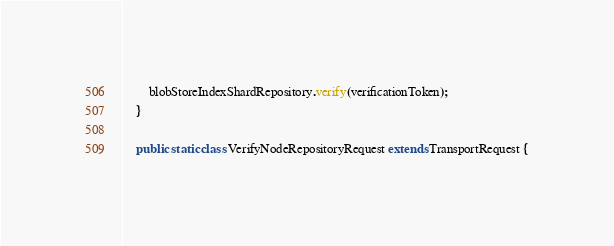Convert code to text. <code><loc_0><loc_0><loc_500><loc_500><_Java_>        blobStoreIndexShardRepository.verify(verificationToken);
    }

    public static class VerifyNodeRepositoryRequest extends TransportRequest {
</code> 